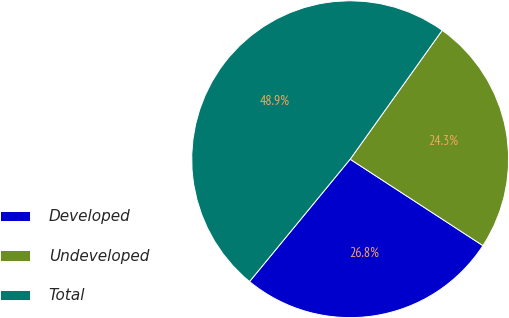Convert chart. <chart><loc_0><loc_0><loc_500><loc_500><pie_chart><fcel>Developed<fcel>Undeveloped<fcel>Total<nl><fcel>26.77%<fcel>24.31%<fcel>48.91%<nl></chart> 